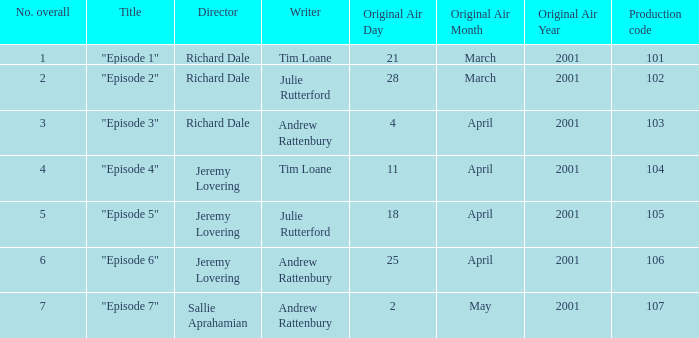When did the episode first air that had a production code of 102? 28March2001. 